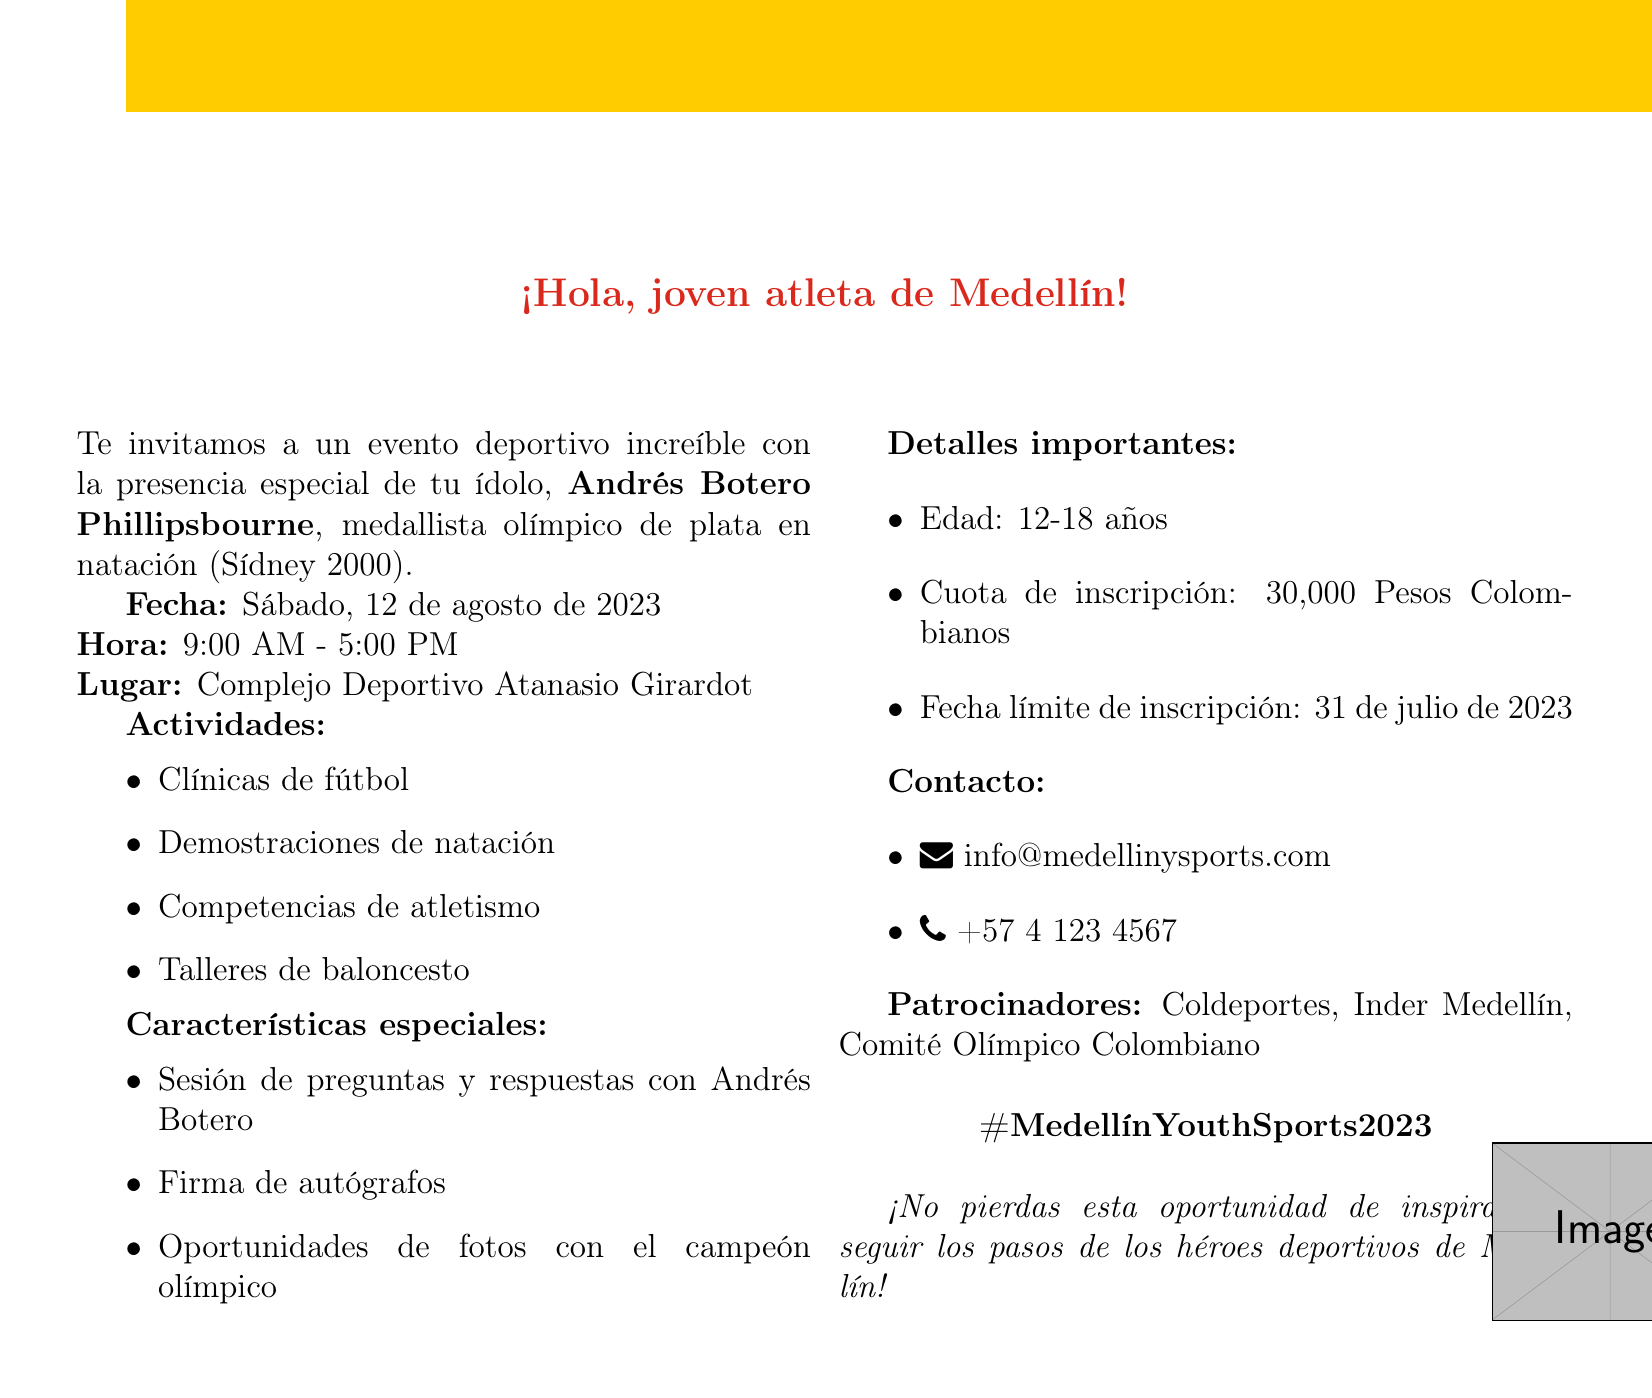What is the event name? The document mentions the event name as the "Medellín Youth Sports Extravaganza."
Answer: Medellín Youth Sports Extravaganza What is the date of the event? The document specifies that the event is on Saturday, August 12, 2023.
Answer: Saturday, August 12, 2023 Where is the venue located? The venue is mentioned in the document as the "Atanasio Girardot Sports Complex."
Answer: Atanasio Girardot Sports Complex Who is the guest star? The document highlights that the guest star is "Andrés Botero Phillipsbourne."
Answer: Andrés Botero Phillipsbourne What activities will be featured at the event? The document lists several activities, including soccer clinics, swimming demonstrations, track and field competitions, and basketball workshops.
Answer: Soccer clinics, swimming demonstrations, track and field competitions, basketball workshops What age group is targeted for this event? The document states that the target audience is young athletes aged 12-18.
Answer: Young athletes aged 12-18 When is the registration deadline? The document indicates that the registration deadline is July 31, 2023.
Answer: July 31, 2023 What is the registration fee? The document mentions that the registration fee is 30,000 Colombian Pesos.
Answer: 30,000 Colombian Pesos What is the goal of the event? The document outlines that the event's goal is to inspire young athletes to pursue excellence in sports.
Answer: Inspire young athletes to pursue excellence in sports 